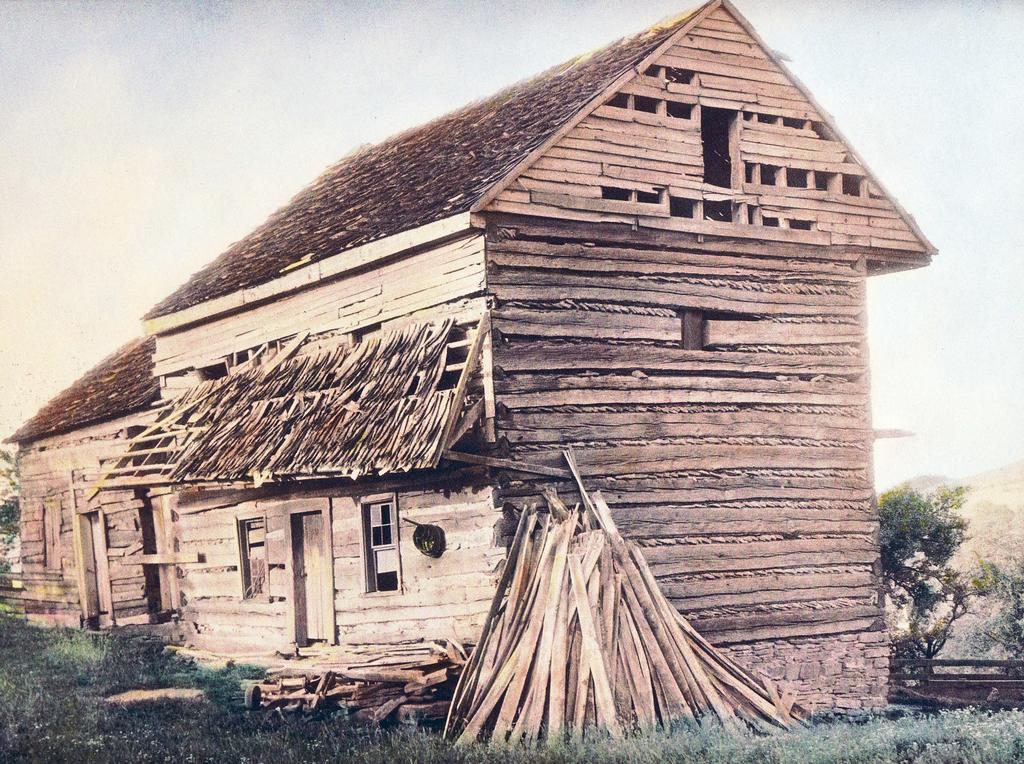Please provide a concise description of this image. In this image we can see the wooden cabin/house. And we can see the windows and some wooden sticks. And we can see the grass, trees. And we can see the sky. 